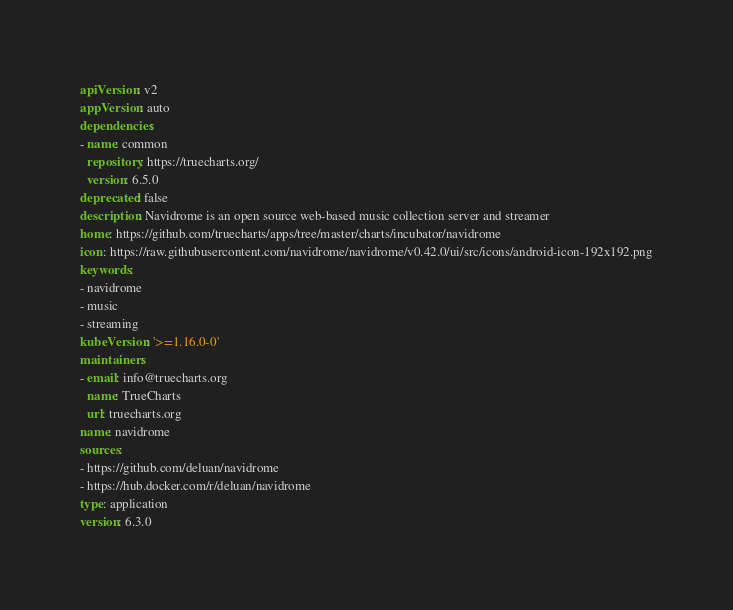Convert code to text. <code><loc_0><loc_0><loc_500><loc_500><_YAML_>apiVersion: v2
appVersion: auto
dependencies:
- name: common
  repository: https://truecharts.org/
  version: 6.5.0
deprecated: false
description: Navidrome is an open source web-based music collection server and streamer
home: https://github.com/truecharts/apps/tree/master/charts/incubator/navidrome
icon: https://raw.githubusercontent.com/navidrome/navidrome/v0.42.0/ui/src/icons/android-icon-192x192.png
keywords:
- navidrome
- music
- streaming
kubeVersion: '>=1.16.0-0'
maintainers:
- email: info@truecharts.org
  name: TrueCharts
  url: truecharts.org
name: navidrome
sources:
- https://github.com/deluan/navidrome
- https://hub.docker.com/r/deluan/navidrome
type: application
version: 6.3.0
</code> 